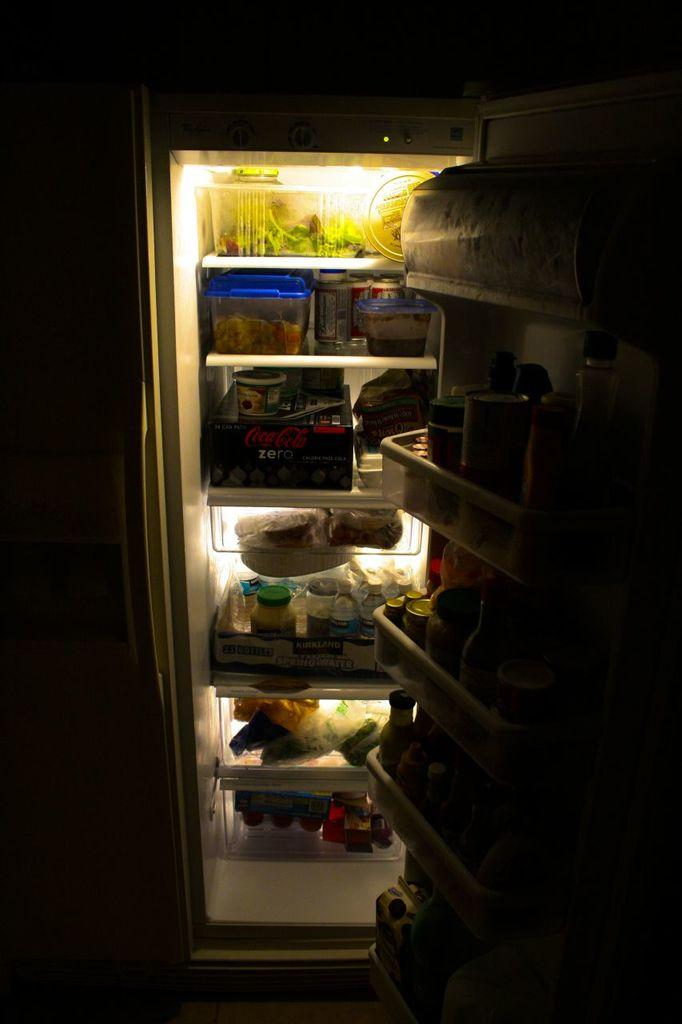<image>
Give a short and clear explanation of the subsequent image. the inside of a dark fridge, with a pack of coke zero on the third shelf 